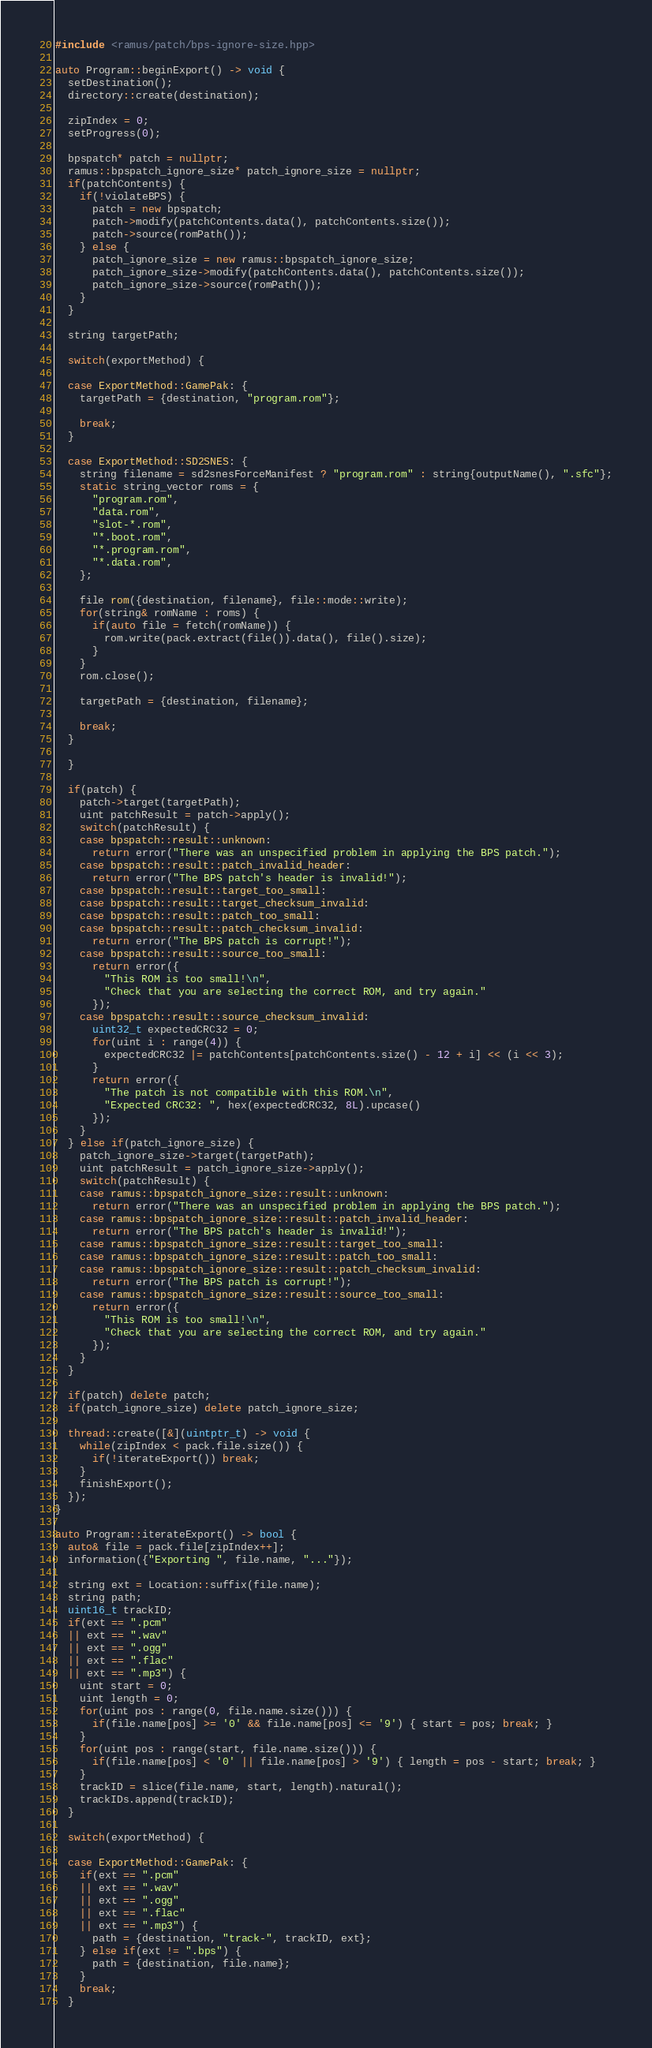Convert code to text. <code><loc_0><loc_0><loc_500><loc_500><_C++_>#include <ramus/patch/bps-ignore-size.hpp>

auto Program::beginExport() -> void {
  setDestination();
  directory::create(destination);

  zipIndex = 0;
  setProgress(0);

  bpspatch* patch = nullptr;
  ramus::bpspatch_ignore_size* patch_ignore_size = nullptr;
  if(patchContents) {
    if(!violateBPS) {
      patch = new bpspatch;
      patch->modify(patchContents.data(), patchContents.size());
      patch->source(romPath());
    } else {
      patch_ignore_size = new ramus::bpspatch_ignore_size;
      patch_ignore_size->modify(patchContents.data(), patchContents.size());
      patch_ignore_size->source(romPath());
    }
  }

  string targetPath;

  switch(exportMethod) {

  case ExportMethod::GamePak: {
    targetPath = {destination, "program.rom"};

    break;
  }

  case ExportMethod::SD2SNES: {
    string filename = sd2snesForceManifest ? "program.rom" : string{outputName(), ".sfc"};
    static string_vector roms = {
      "program.rom",
      "data.rom",
      "slot-*.rom",
      "*.boot.rom",
      "*.program.rom",
      "*.data.rom",
    };

    file rom({destination, filename}, file::mode::write);
    for(string& romName : roms) {
      if(auto file = fetch(romName)) {
        rom.write(pack.extract(file()).data(), file().size);
      }
    }
    rom.close();

    targetPath = {destination, filename};

    break;
  }

  }

  if(patch) {
    patch->target(targetPath);
    uint patchResult = patch->apply();
    switch(patchResult) {
    case bpspatch::result::unknown:
      return error("There was an unspecified problem in applying the BPS patch.");
    case bpspatch::result::patch_invalid_header:
      return error("The BPS patch's header is invalid!");
    case bpspatch::result::target_too_small:
    case bpspatch::result::target_checksum_invalid:
    case bpspatch::result::patch_too_small:
    case bpspatch::result::patch_checksum_invalid:
      return error("The BPS patch is corrupt!");
    case bpspatch::result::source_too_small:
      return error({
        "This ROM is too small!\n",
        "Check that you are selecting the correct ROM, and try again."
      });
    case bpspatch::result::source_checksum_invalid:
      uint32_t expectedCRC32 = 0;
      for(uint i : range(4)) {
        expectedCRC32 |= patchContents[patchContents.size() - 12 + i] << (i << 3);
      }
      return error({
        "The patch is not compatible with this ROM.\n",
        "Expected CRC32: ", hex(expectedCRC32, 8L).upcase()
      });
    }
  } else if(patch_ignore_size) {
    patch_ignore_size->target(targetPath);
    uint patchResult = patch_ignore_size->apply();
    switch(patchResult) {
    case ramus::bpspatch_ignore_size::result::unknown:
      return error("There was an unspecified problem in applying the BPS patch.");
    case ramus::bpspatch_ignore_size::result::patch_invalid_header:
      return error("The BPS patch's header is invalid!");
    case ramus::bpspatch_ignore_size::result::target_too_small:
    case ramus::bpspatch_ignore_size::result::patch_too_small:
    case ramus::bpspatch_ignore_size::result::patch_checksum_invalid:
      return error("The BPS patch is corrupt!");
    case ramus::bpspatch_ignore_size::result::source_too_small:
      return error({
        "This ROM is too small!\n",
        "Check that you are selecting the correct ROM, and try again."
      });
    }
  }

  if(patch) delete patch;
  if(patch_ignore_size) delete patch_ignore_size;

  thread::create([&](uintptr_t) -> void {
    while(zipIndex < pack.file.size()) {
      if(!iterateExport()) break;
    }
    finishExport();
  });
}

auto Program::iterateExport() -> bool {
  auto& file = pack.file[zipIndex++];
  information({"Exporting ", file.name, "..."});

  string ext = Location::suffix(file.name);
  string path;
  uint16_t trackID;
  if(ext == ".pcm"
  || ext == ".wav"
  || ext == ".ogg"
  || ext == ".flac"
  || ext == ".mp3") {
    uint start = 0;
    uint length = 0;
    for(uint pos : range(0, file.name.size())) {
      if(file.name[pos] >= '0' && file.name[pos] <= '9') { start = pos; break; }
    }
    for(uint pos : range(start, file.name.size())) {
      if(file.name[pos] < '0' || file.name[pos] > '9') { length = pos - start; break; }
    }
    trackID = slice(file.name, start, length).natural();
    trackIDs.append(trackID);
  }

  switch(exportMethod) {

  case ExportMethod::GamePak: {
    if(ext == ".pcm"
    || ext == ".wav"
    || ext == ".ogg"
    || ext == ".flac"
    || ext == ".mp3") {
      path = {destination, "track-", trackID, ext};
    } else if(ext != ".bps") {
      path = {destination, file.name};
    }
    break;
  }
</code> 